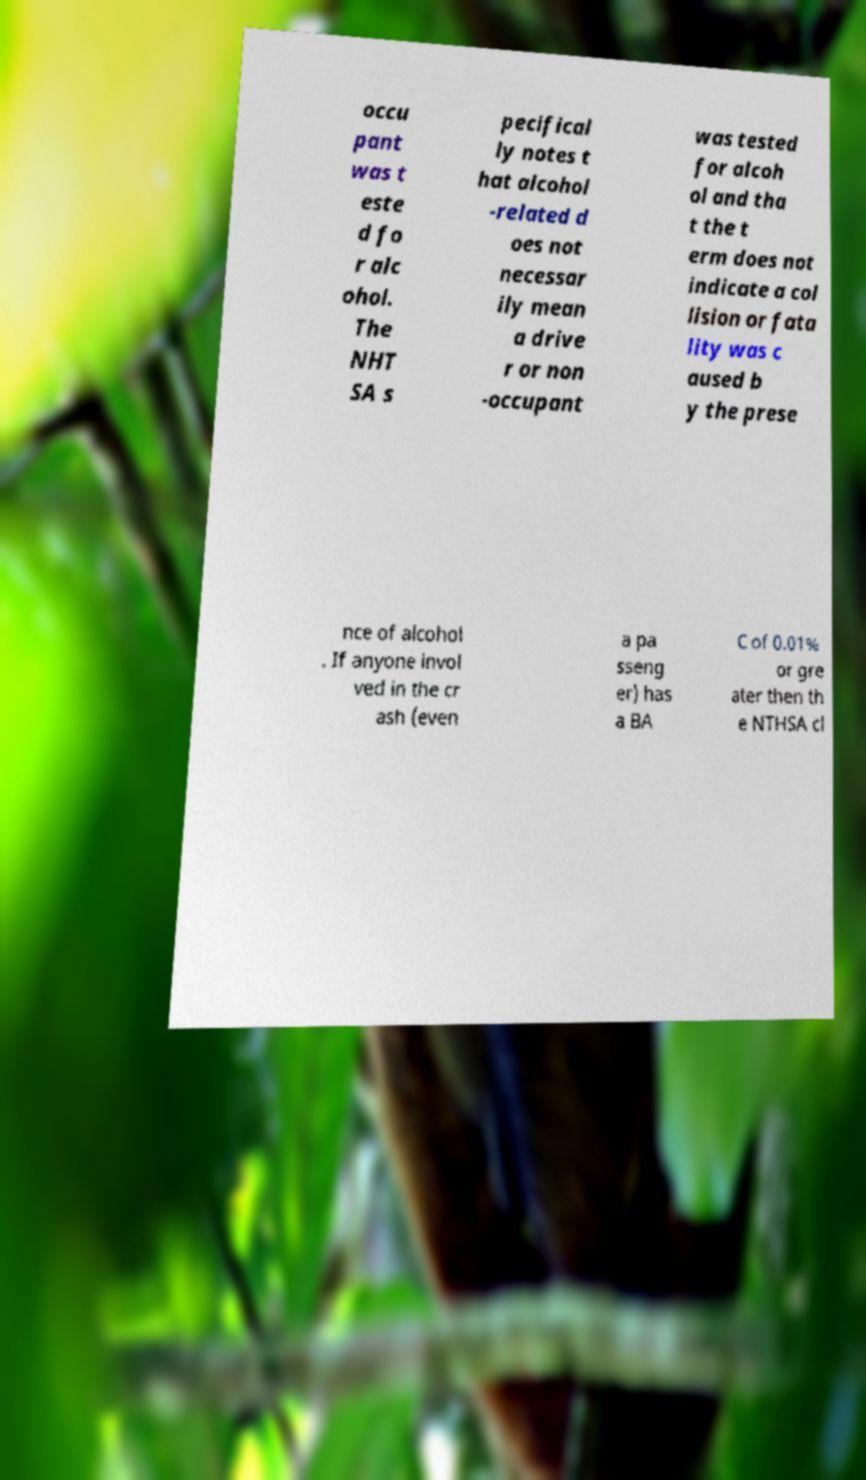Could you assist in decoding the text presented in this image and type it out clearly? occu pant was t este d fo r alc ohol. The NHT SA s pecifical ly notes t hat alcohol -related d oes not necessar ily mean a drive r or non -occupant was tested for alcoh ol and tha t the t erm does not indicate a col lision or fata lity was c aused b y the prese nce of alcohol . If anyone invol ved in the cr ash (even a pa sseng er) has a BA C of 0.01% or gre ater then th e NTHSA cl 